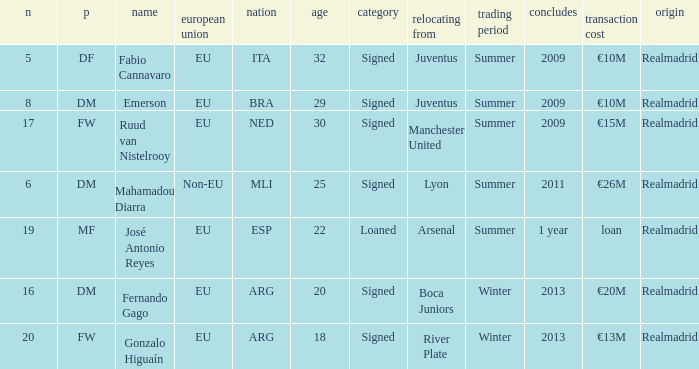What is the EU status of ESP? EU. 